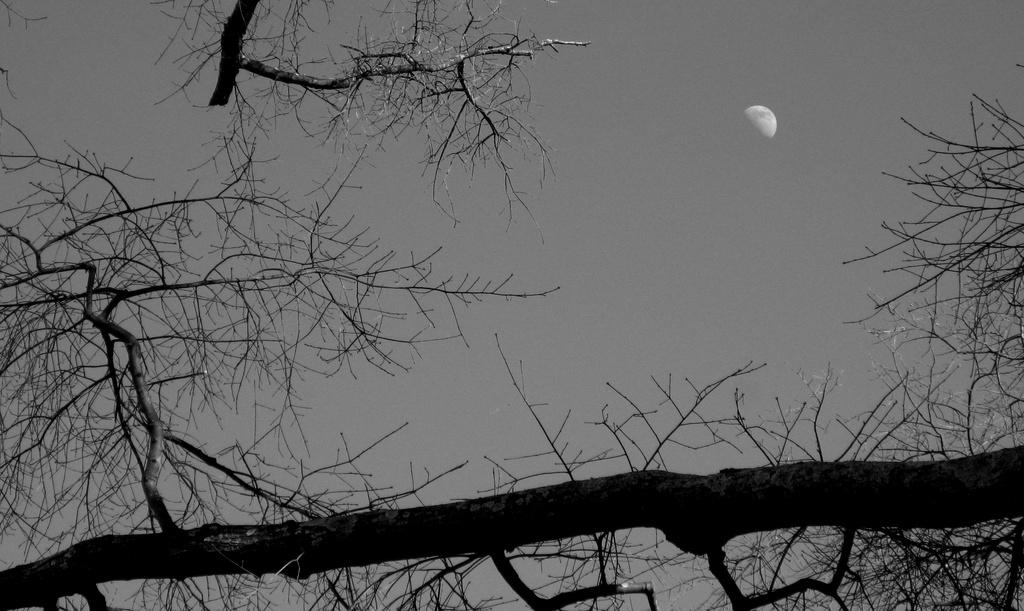What type of vegetation can be seen in the image? There are trees in the image. What part of the natural environment is visible in the image? The sky is visible in the image. What celestial body can be seen in the image? The moon is present in the image. What type of salt can be seen on the seashore in the image? There is no seashore or salt present in the image; it features trees, the sky, and the moon. 